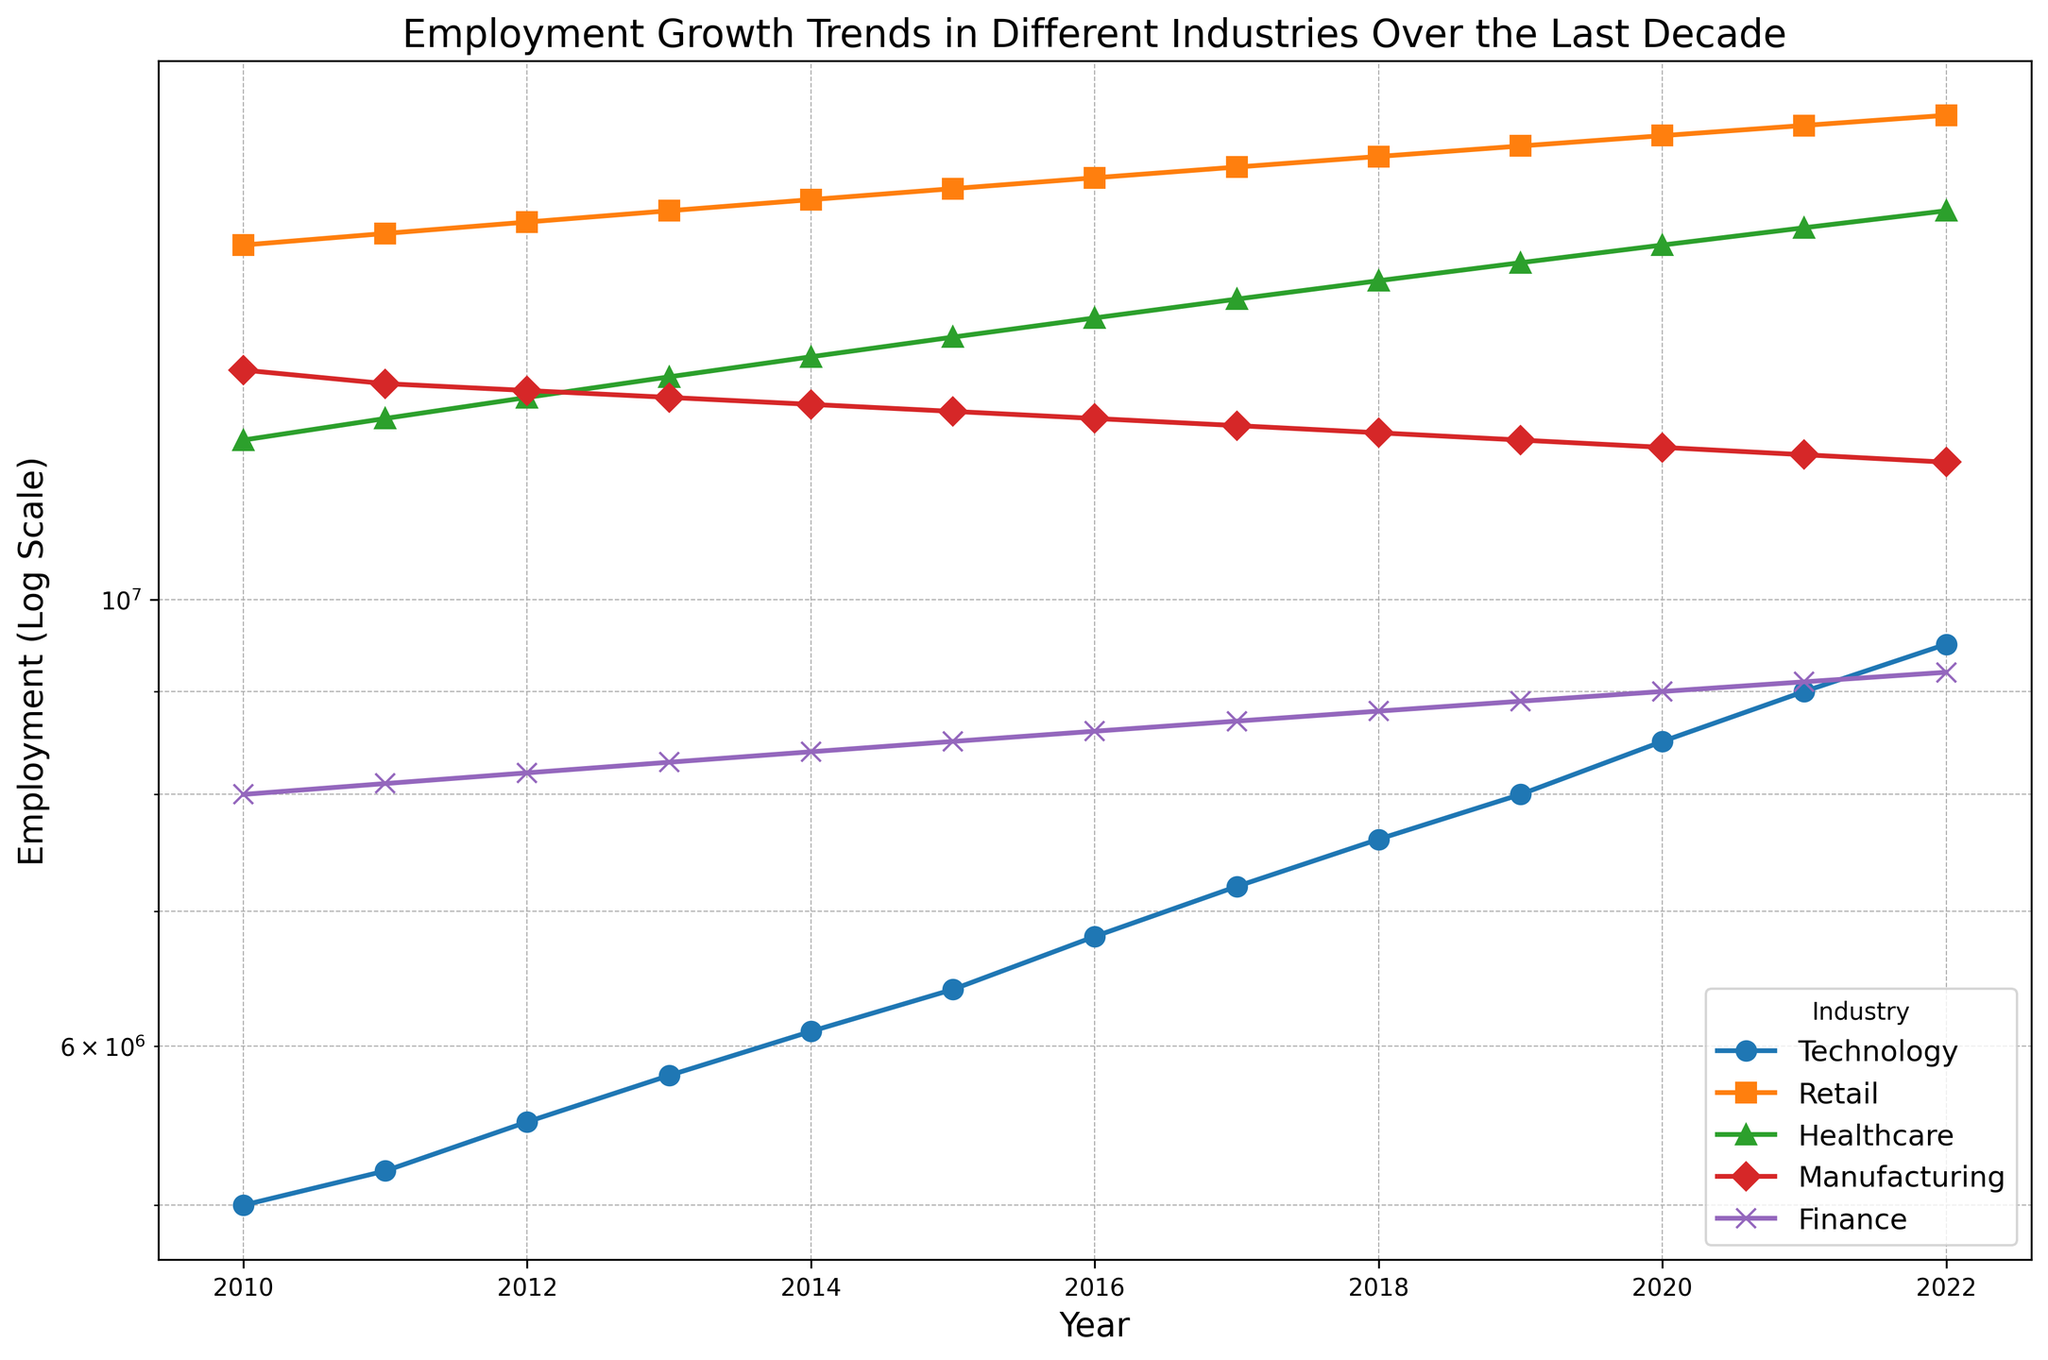Which industry shows the highest employment growth by 2022? The graph shows all the industries' employment over time, and 2022 is the last data point. By tracing the lines to their endpoints in 2022, we observe that the Retail industry has the highest employment value among all industries.
Answer: Retail Which industry had the least employment growth from 2010 to 2022? Comparing all industries from 2010 to 2022, the employment line for Manufacturing has the least spread, indicating the least growth.
Answer: Manufacturing By what factor has employment in the Technology industry grown from 2010 to 2022? The Technology industry's employment in 2010 was 5,000,000 and in 2022 was 9,500,000. The growth factor is calculated by dividing 9,500,000 by 5,000,000, resulting in a factor of 1.9.
Answer: 1.9 Which two industries have closely intersecting lines in 2022, indicating similar employment levels? In 2022, Healthcare and Retail show closely intersecting lines, indicating they have similar employment levels.
Answer: Healthcare and Retail Are there years where no industry shows a decline in employment? Observing the trends from 2010 to 2022, each industry's employment line either remains constant or increases every year without any visible decline.
Answer: Yes Which industry experienced the most fluctuation in employment growth? By examining the lines' smoothness across the graph, Manufacturing shows the most fluctuation with noticeable dips and rises from year to year.
Answer: Manufacturing How many industries achieved more than 10,000,000 in employment by 2022? By looking at the final points in 2022 on a log scale, Technology, Retail, and Healthcare exceed the 10,000,000 employment mark.
Answer: 3 In which years did Retail and Healthcare industries have approximately equal employment? The lines for Retail and Healthcare get very close between 2018 and 2019, indicating they had approximately equal employment during those years.
Answer: 2018-2019 Which industry had employment growing at the most consistent rate? The line for Finance is the smoothest and straightest on the log scale, indicating a consistent growth rate throughout the years.
Answer: Finance 